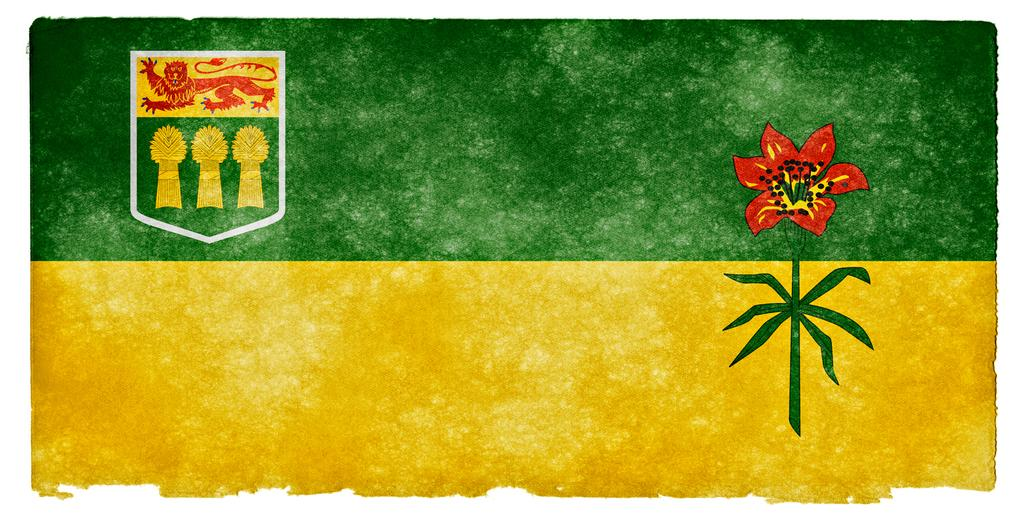What is the main subject of the image? There is a painting in the image. Can you describe any specific elements within the painting? The painting has a flower on the right side and a symbol on the left side, which appears to be a flag. What colors are present at the top and bottom of the painting? The top of the painting is green in color, and the bottom is yellow in color. How many boys are depicted in the painting? There are no boys depicted in the painting; it features a flower and a symbol that appears to be a flag. What type of war is being fought in the painting? There is no war depicted in the painting; it is a painting of a flower and a symbol that appears to be a flag. 